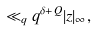<formula> <loc_0><loc_0><loc_500><loc_500>\ll _ { q } q ^ { \delta + Q } | z | _ { \infty } ,</formula> 